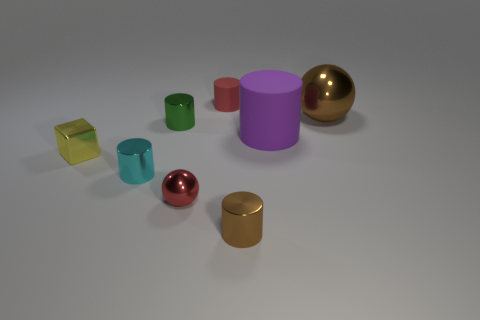There is a block; does it have the same size as the matte cylinder that is behind the big brown object?
Make the answer very short. Yes. There is a cylinder in front of the small red shiny thing; what color is it?
Give a very brief answer. Brown. The shiny object that is the same color as the small rubber object is what shape?
Ensure brevity in your answer.  Sphere. What shape is the red thing in front of the small yellow block?
Provide a short and direct response. Sphere. How many blue objects are large rubber cylinders or large things?
Your response must be concise. 0. Does the tiny block have the same material as the tiny green cylinder?
Your answer should be very brief. Yes. How many small green shiny cylinders are in front of the yellow object?
Keep it short and to the point. 0. The small cylinder that is behind the brown cylinder and in front of the green cylinder is made of what material?
Ensure brevity in your answer.  Metal. How many blocks are either cyan shiny objects or small matte objects?
Provide a short and direct response. 0. There is a brown thing that is the same shape as the cyan shiny thing; what is it made of?
Give a very brief answer. Metal. 